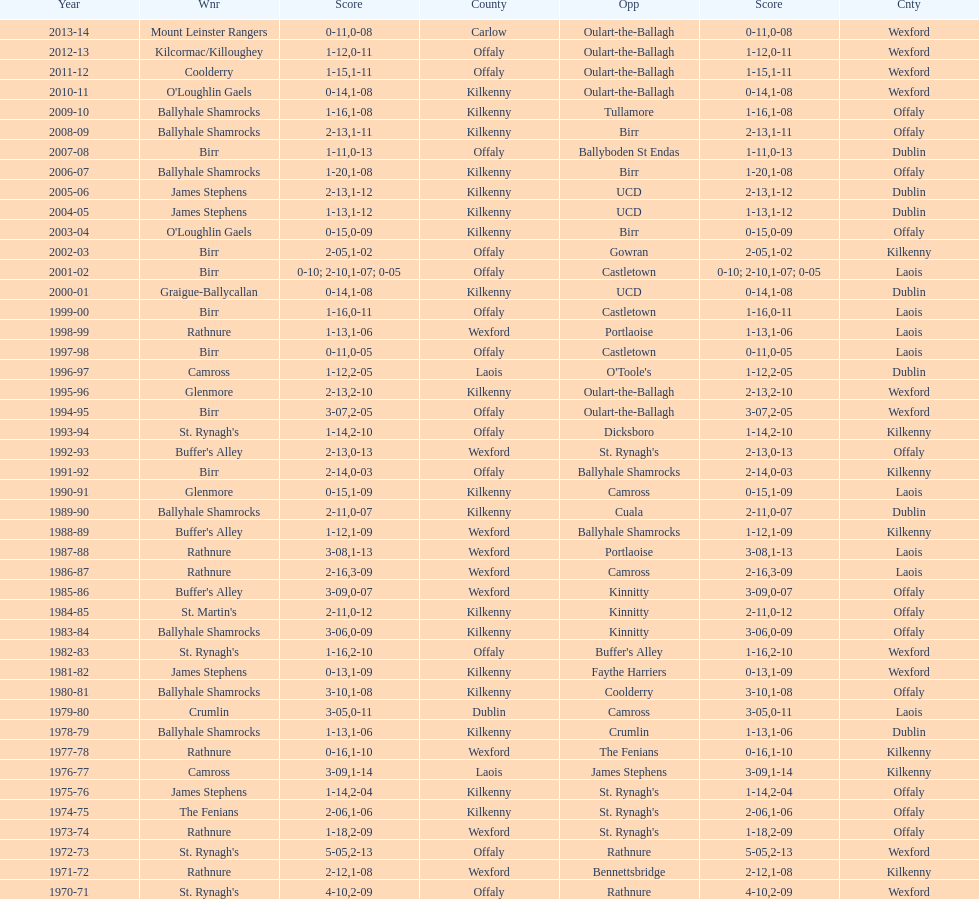How many consecutive years did rathnure win? 2. 